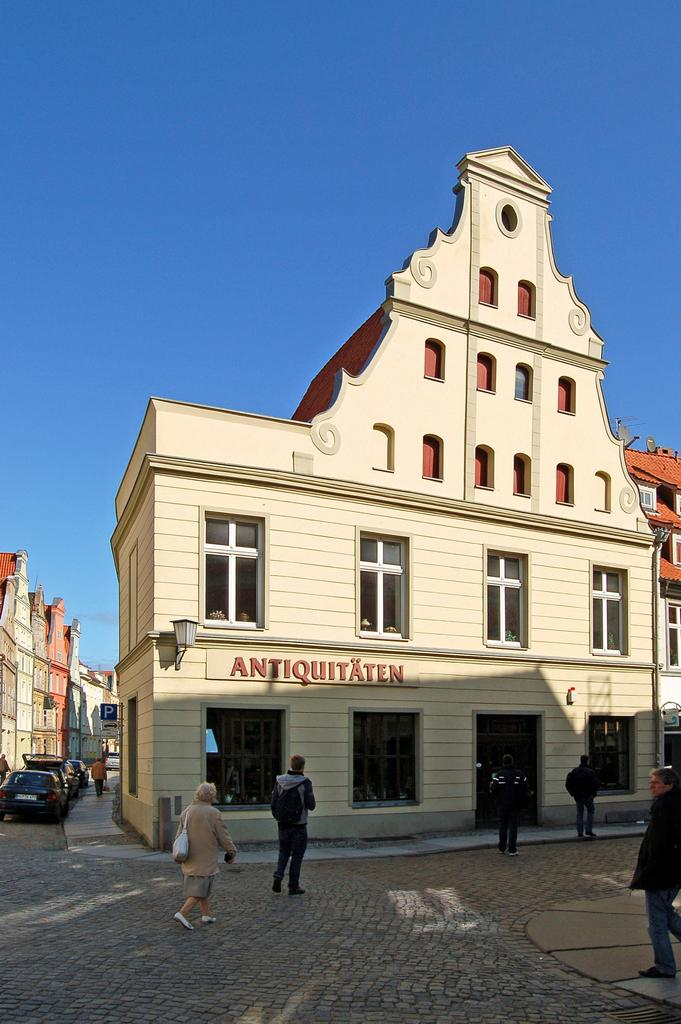<image>
Create a compact narrative representing the image presented. A sign marks the Antiquitaten, where several people are headed on foot. 